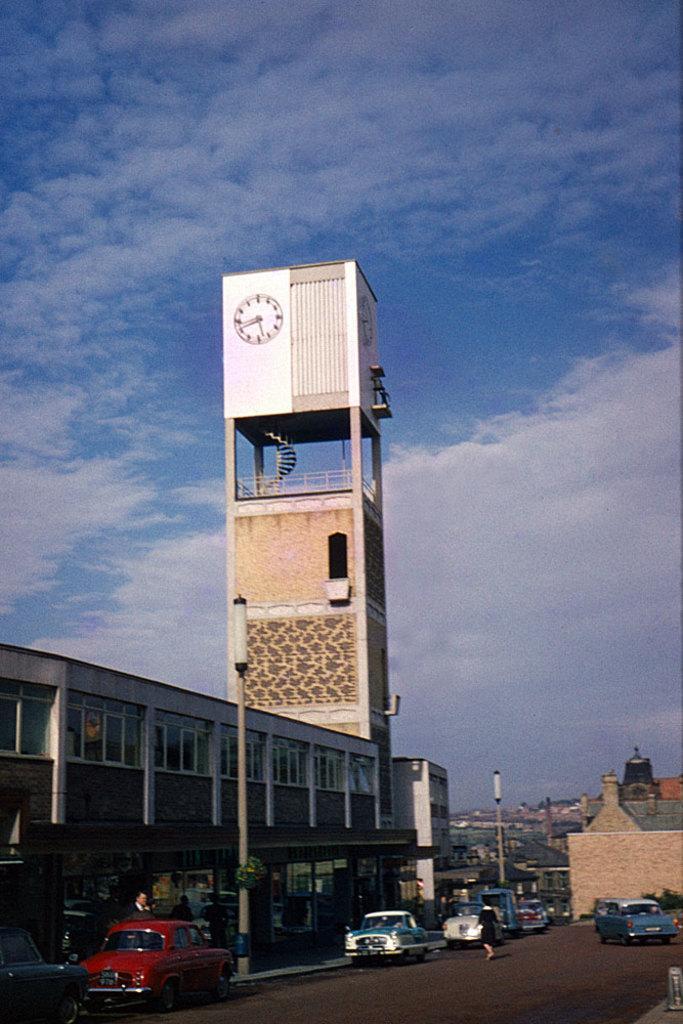In one or two sentences, can you explain what this image depicts? In the foreground of this image, there are few vehicles on the road and a person walking on it. On the left, there is a building, poles and a tower. In the background, there are buildings. At the top, there is the sky. 